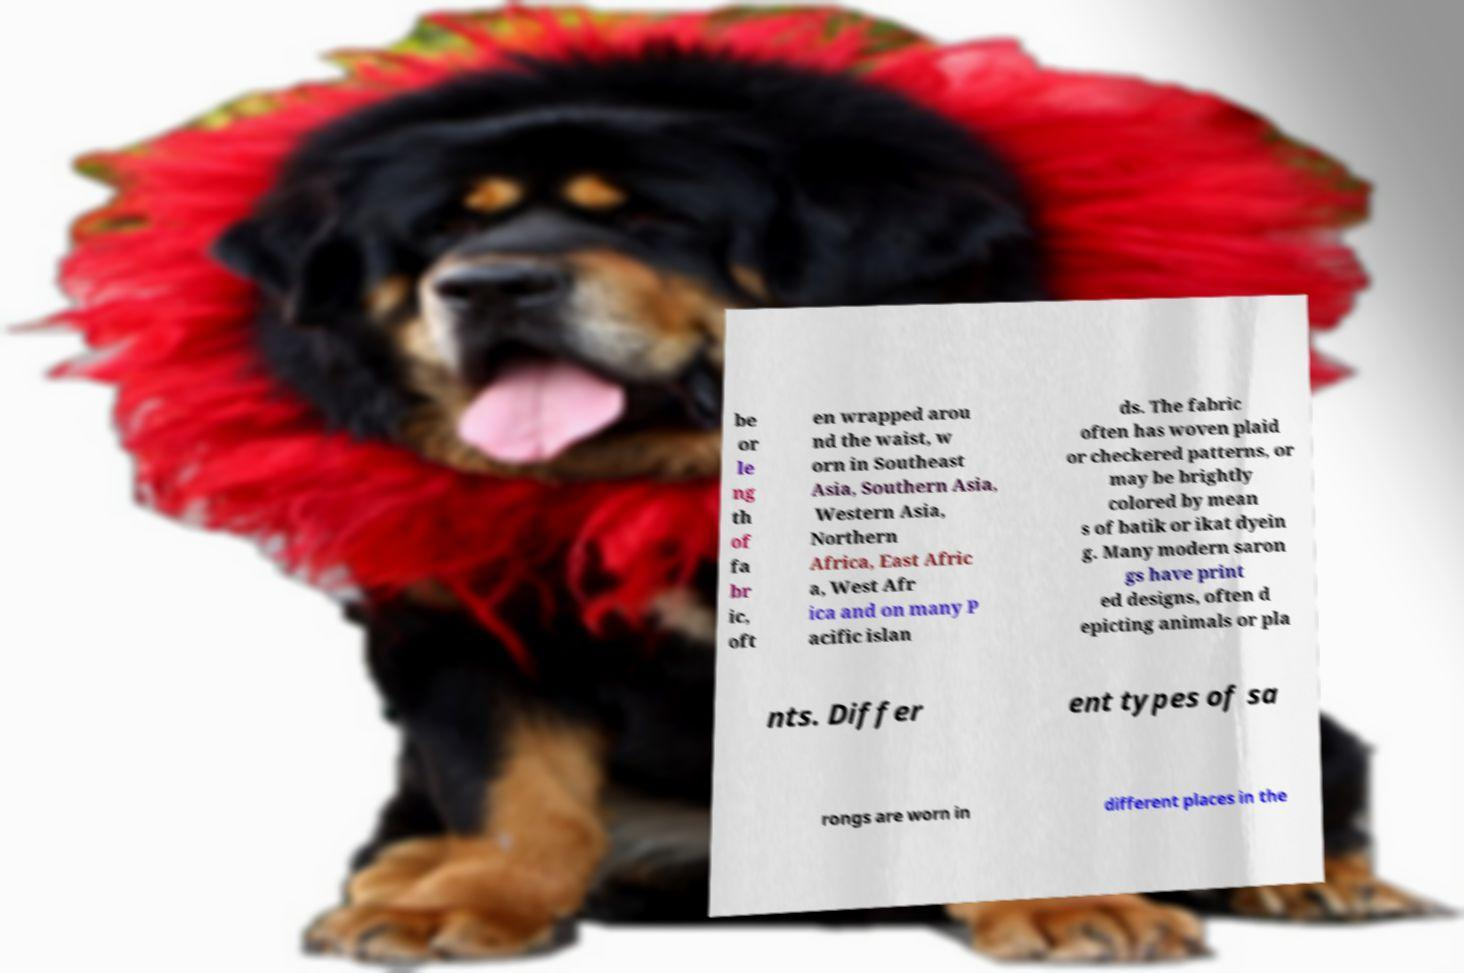What messages or text are displayed in this image? I need them in a readable, typed format. be or le ng th of fa br ic, oft en wrapped arou nd the waist, w orn in Southeast Asia, Southern Asia, Western Asia, Northern Africa, East Afric a, West Afr ica and on many P acific islan ds. The fabric often has woven plaid or checkered patterns, or may be brightly colored by mean s of batik or ikat dyein g. Many modern saron gs have print ed designs, often d epicting animals or pla nts. Differ ent types of sa rongs are worn in different places in the 